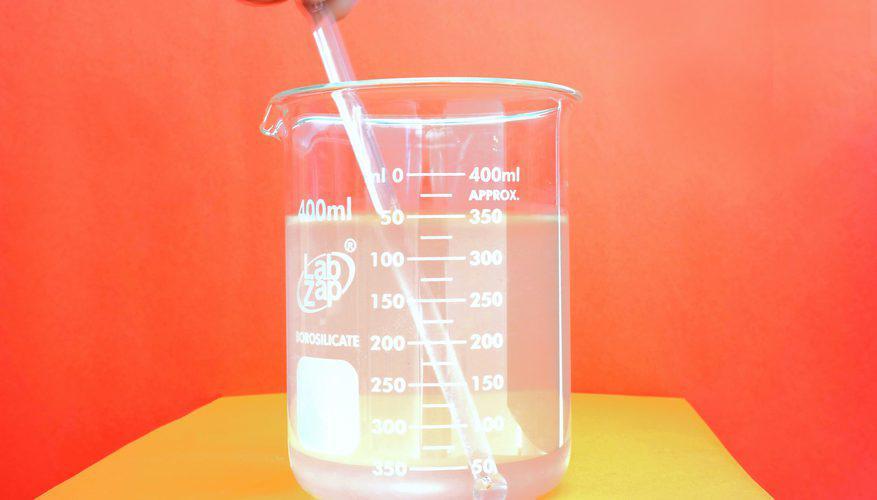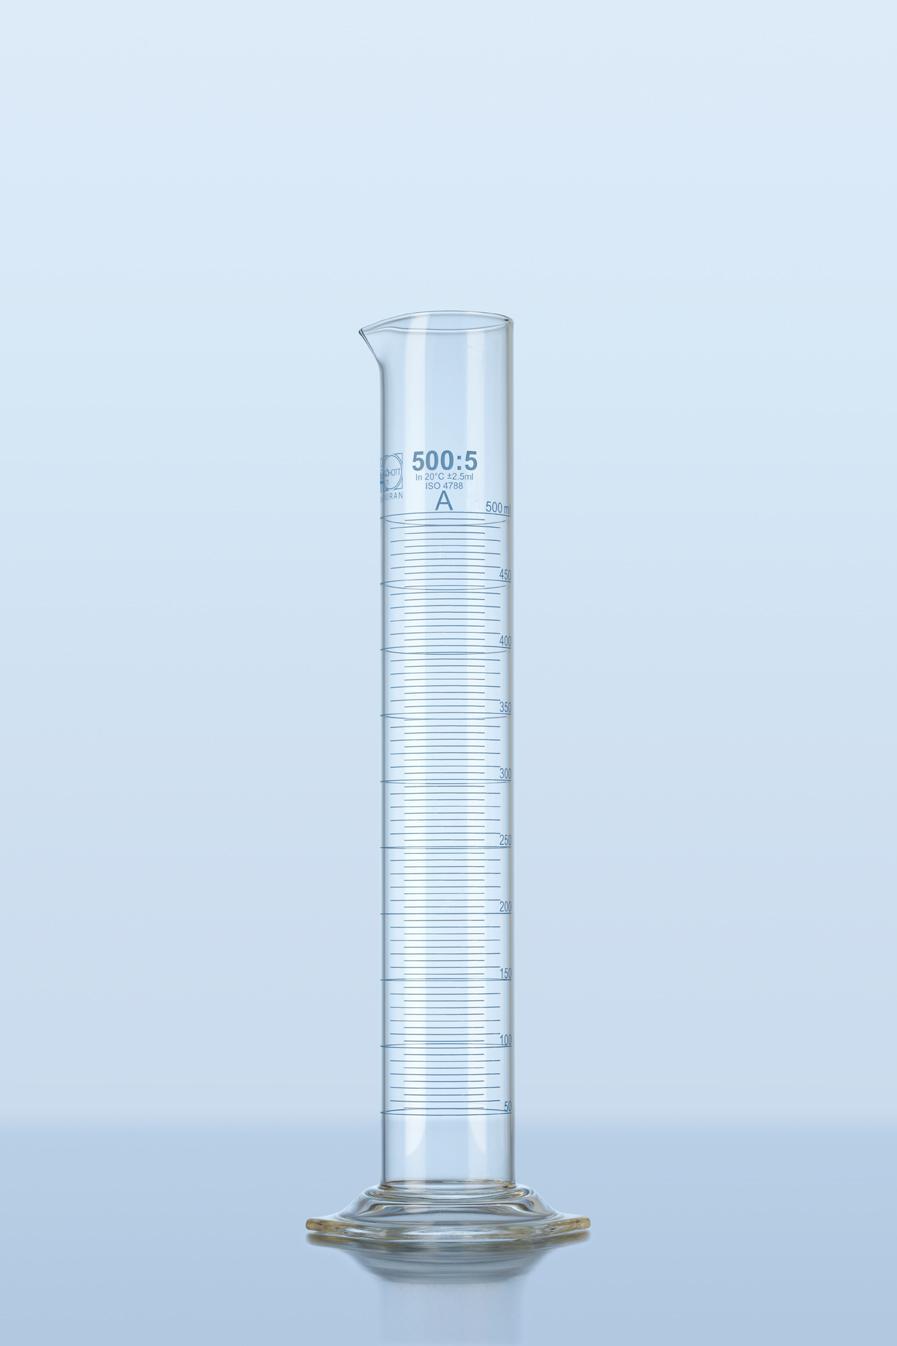The first image is the image on the left, the second image is the image on the right. For the images shown, is this caption "Four or more beakers are visible." true? Answer yes or no. No. The first image is the image on the left, the second image is the image on the right. Analyze the images presented: Is the assertion "There are at least four beaker." valid? Answer yes or no. No. 